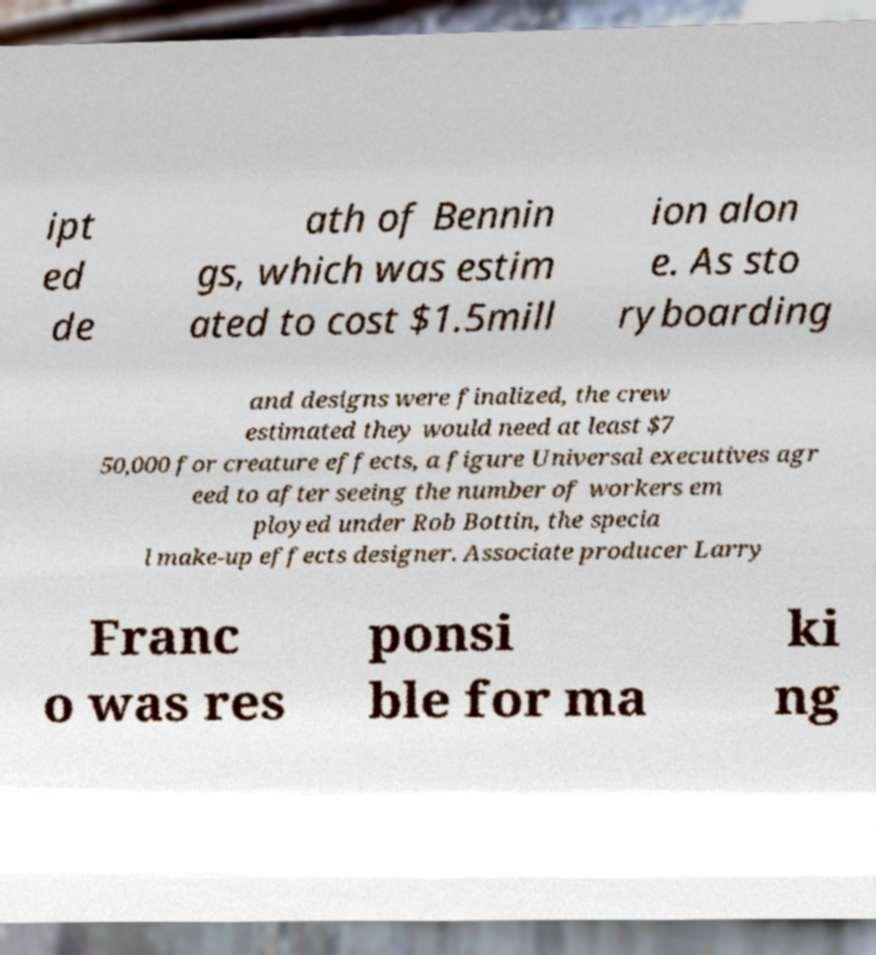Could you extract and type out the text from this image? ipt ed de ath of Bennin gs, which was estim ated to cost $1.5mill ion alon e. As sto ryboarding and designs were finalized, the crew estimated they would need at least $7 50,000 for creature effects, a figure Universal executives agr eed to after seeing the number of workers em ployed under Rob Bottin, the specia l make-up effects designer. Associate producer Larry Franc o was res ponsi ble for ma ki ng 